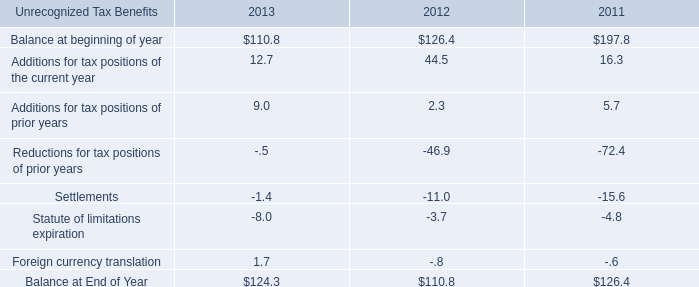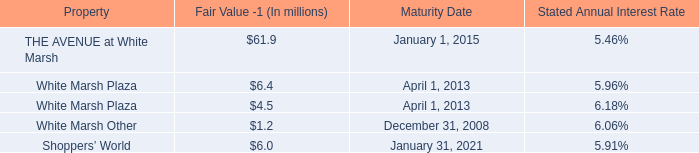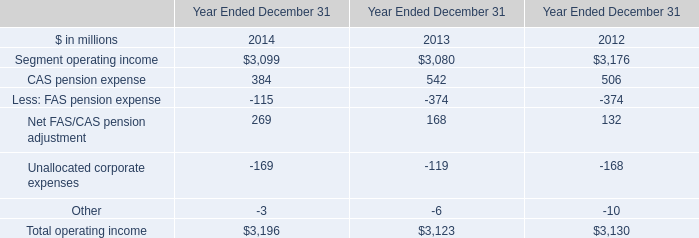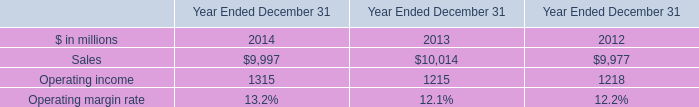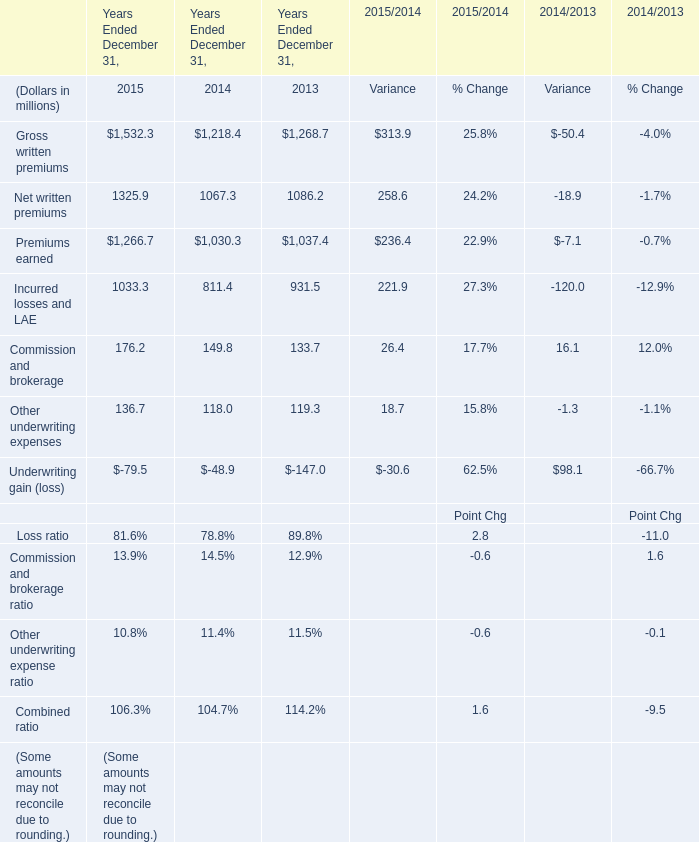What's the average of Premiums earned of Years Ended December 31, 2015, and Sales of Year Ended December 31 2012 ? 
Computations: ((1266.7 + 9977.0) / 2)
Answer: 5621.85. 